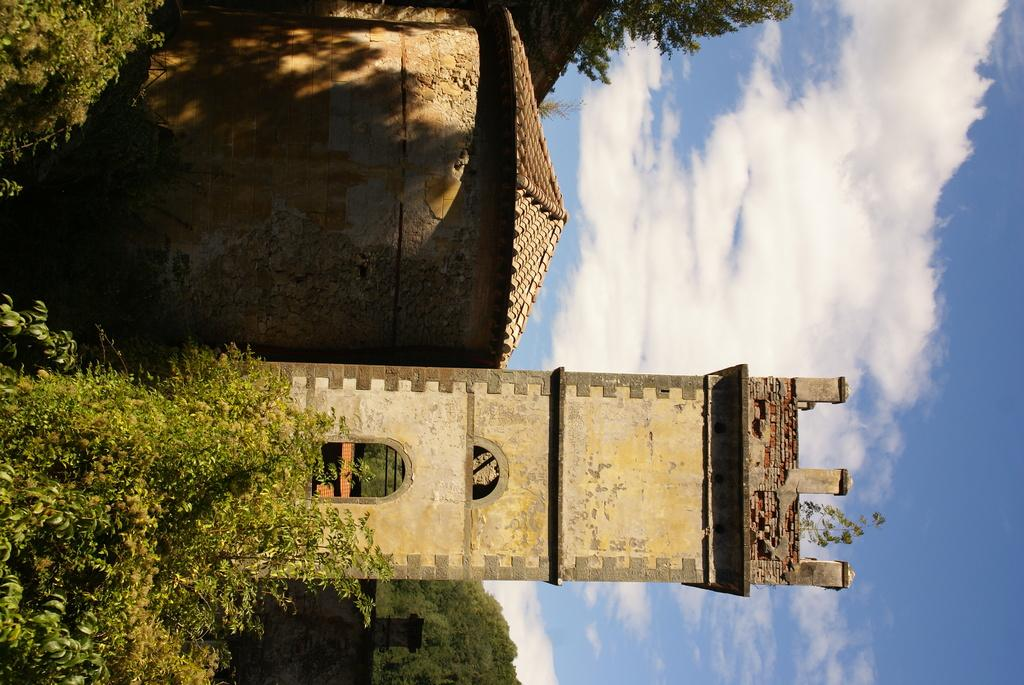What type of structure is present in the image? There is a tower in the image. What other type of structure can be seen in the image? There is a shed in the image. What natural elements are visible in the image? Trees arees are visible in the image. What is visible in the background of the image? The sky is visible in the background of the image. Can you see any ears on the tower in the image? There are no ears present in the image, as it features a tower and a shed in a natural setting with trees and the sky. 